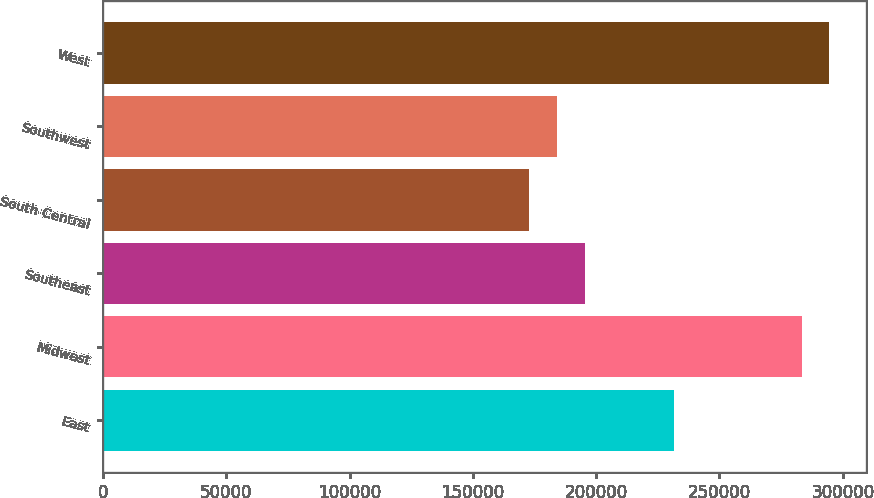<chart> <loc_0><loc_0><loc_500><loc_500><bar_chart><fcel>East<fcel>Midwest<fcel>Southeast<fcel>South Central<fcel>Southwest<fcel>West<nl><fcel>231400<fcel>283300<fcel>195280<fcel>172700<fcel>183990<fcel>294590<nl></chart> 